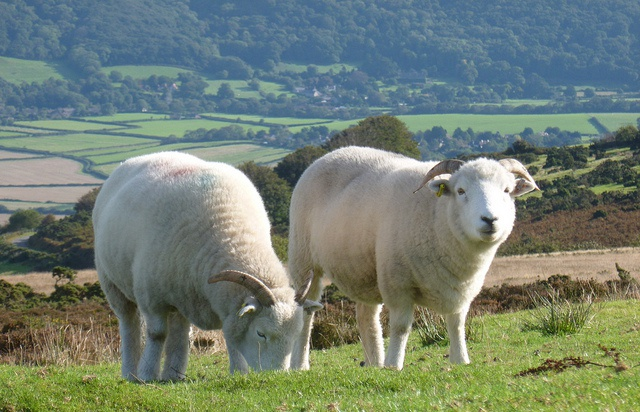Describe the objects in this image and their specific colors. I can see sheep in gray, darkgray, and white tones and sheep in gray, ivory, and darkgray tones in this image. 